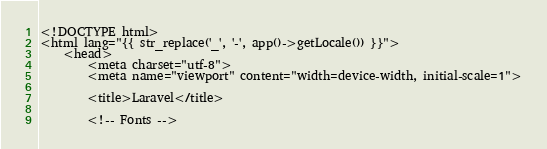<code> <loc_0><loc_0><loc_500><loc_500><_PHP_><!DOCTYPE html>
<html lang="{{ str_replace('_', '-', app()->getLocale()) }}">
    <head>
        <meta charset="utf-8">
        <meta name="viewport" content="width=device-width, initial-scale=1">

        <title>Laravel</title>

        <!-- Fonts --></code> 